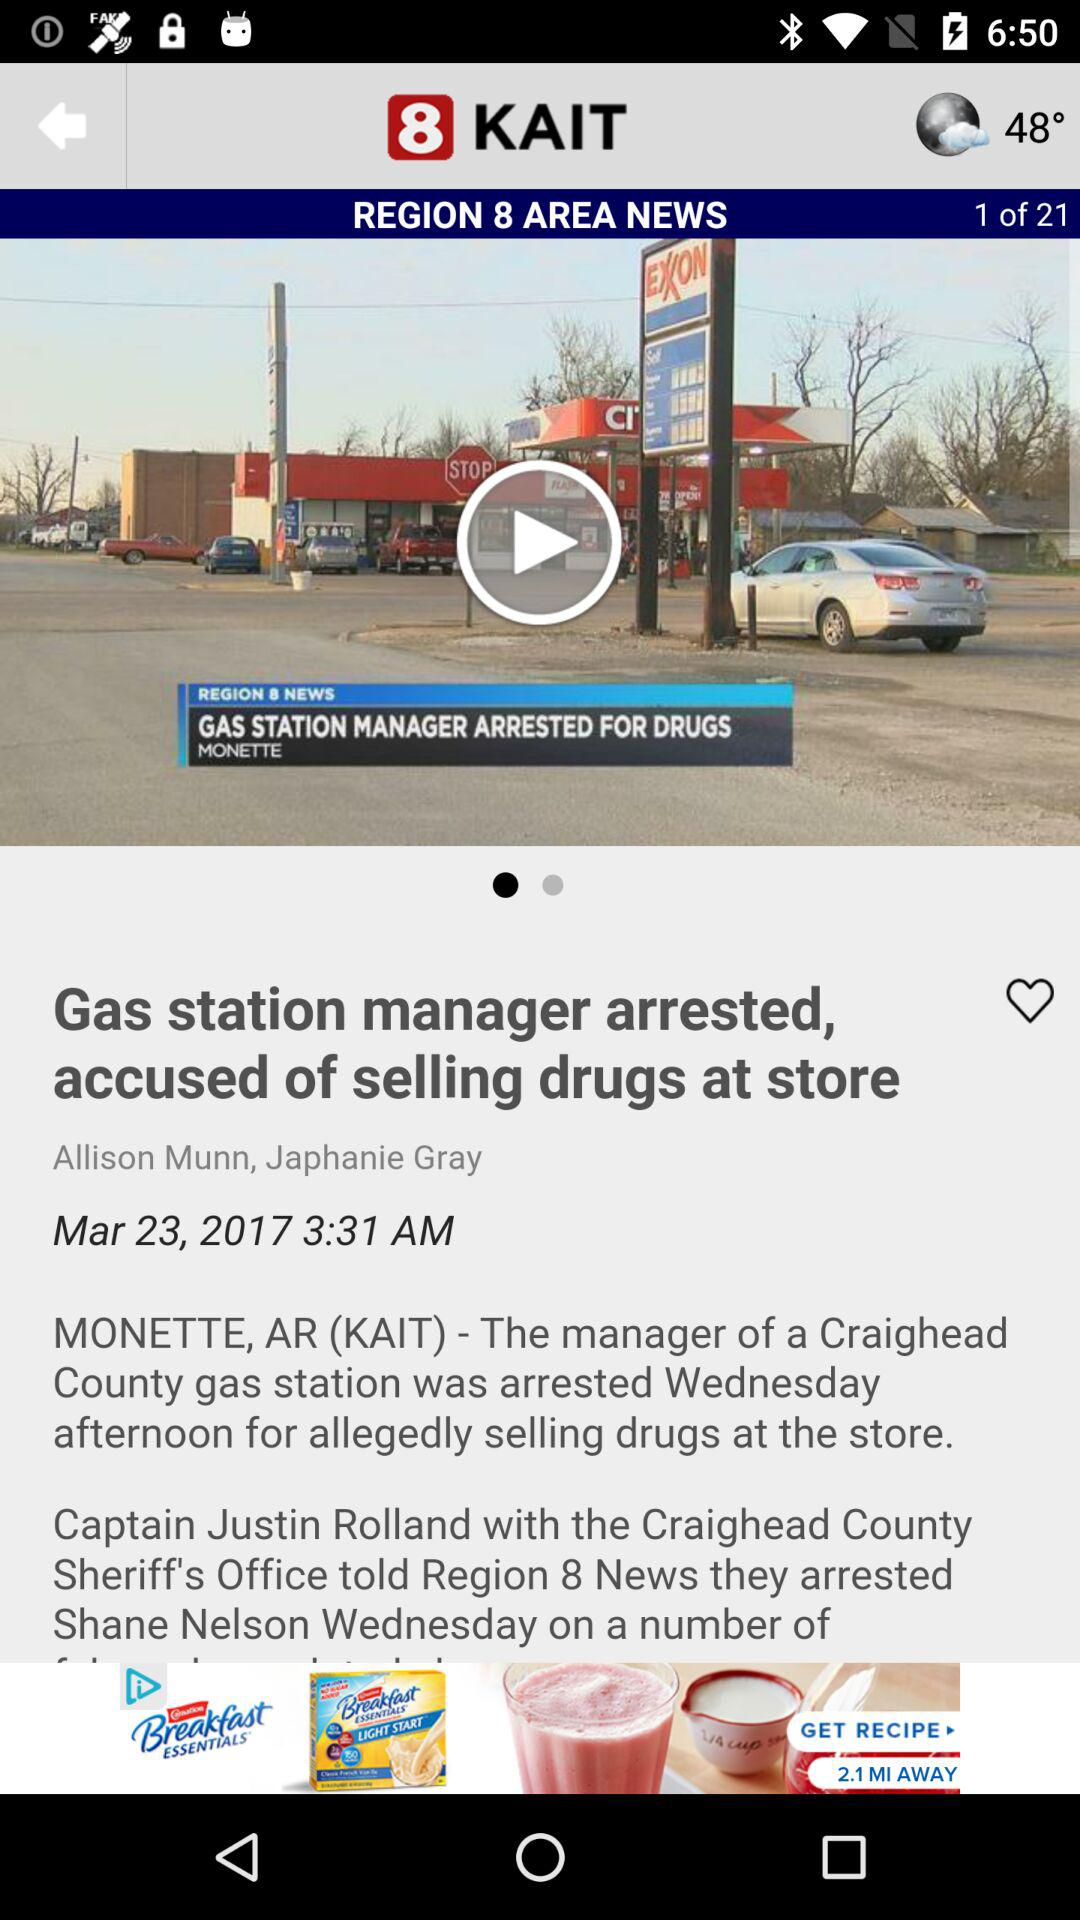What is the total number of pages? The total number of pages is 21. 